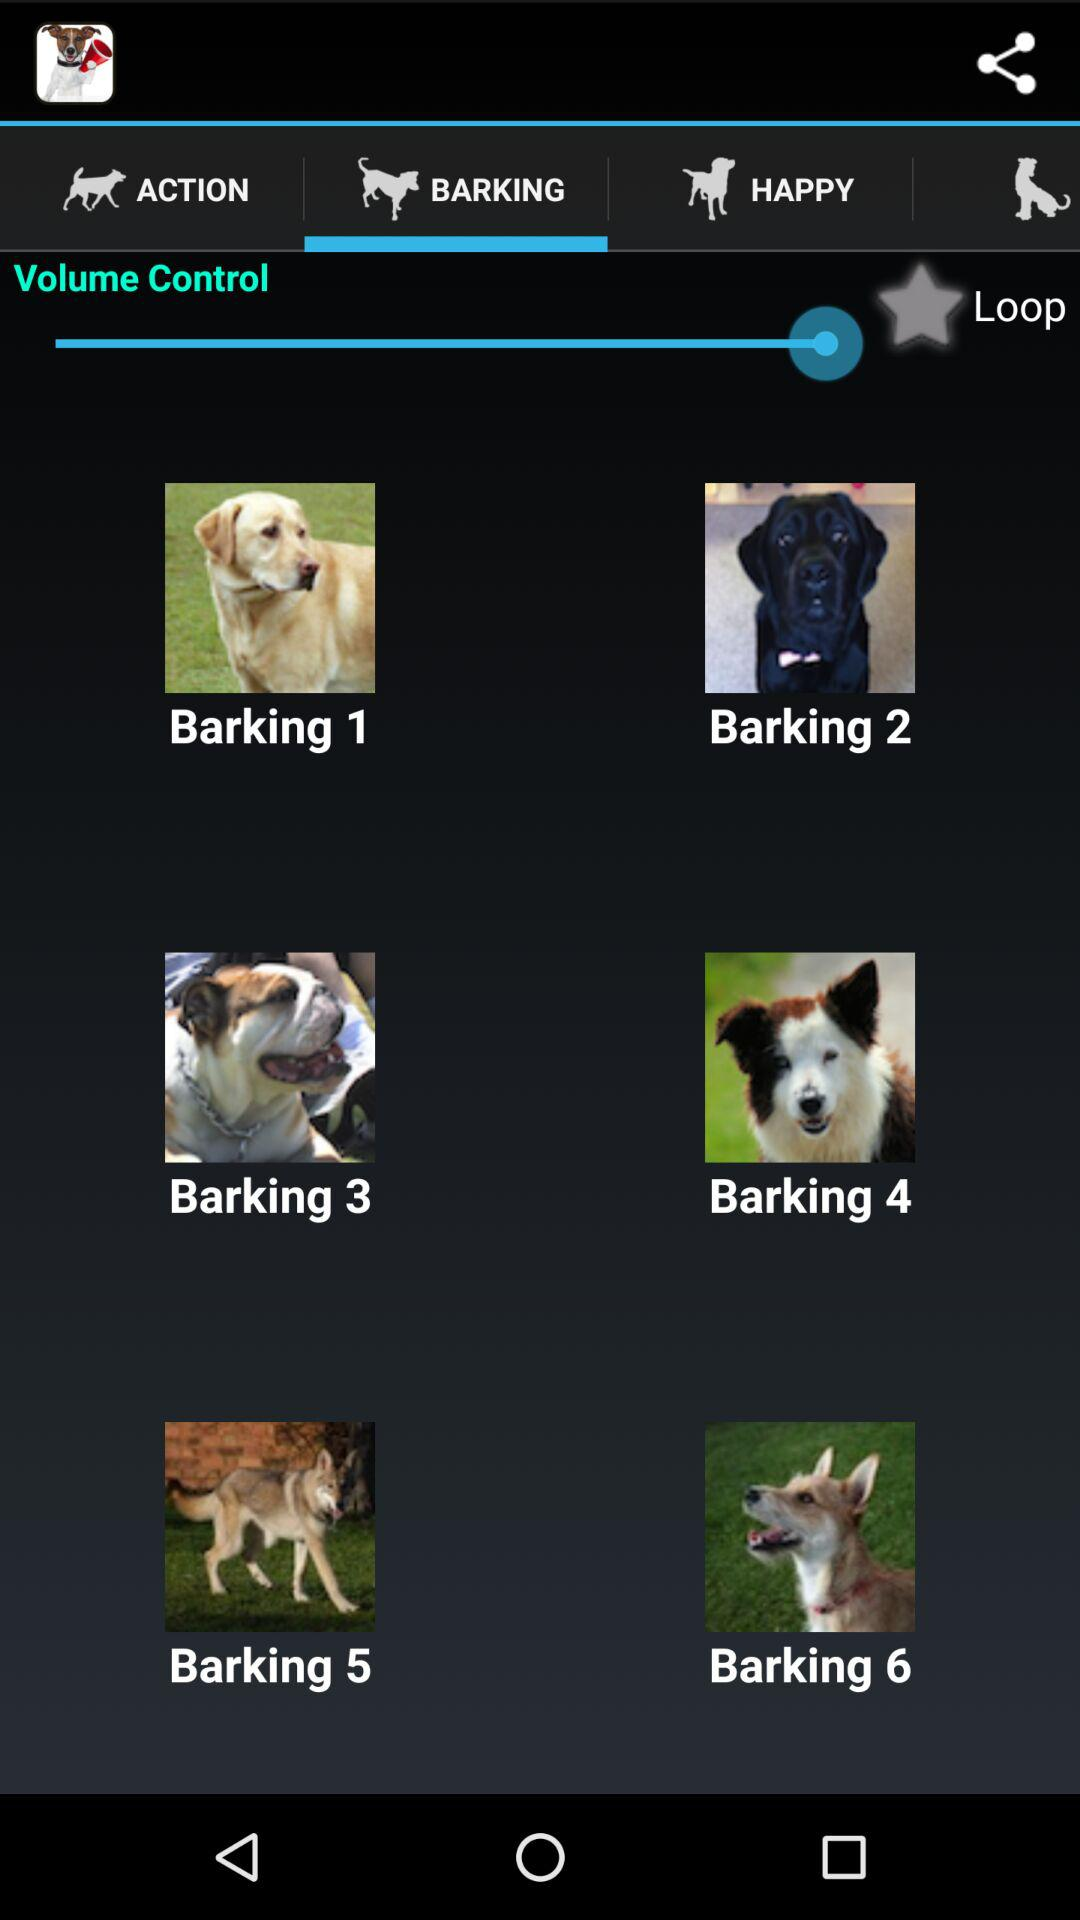How many more items have a dog standing on the grass than items with a dog sitting on a bed?
Answer the question using a single word or phrase. 2 